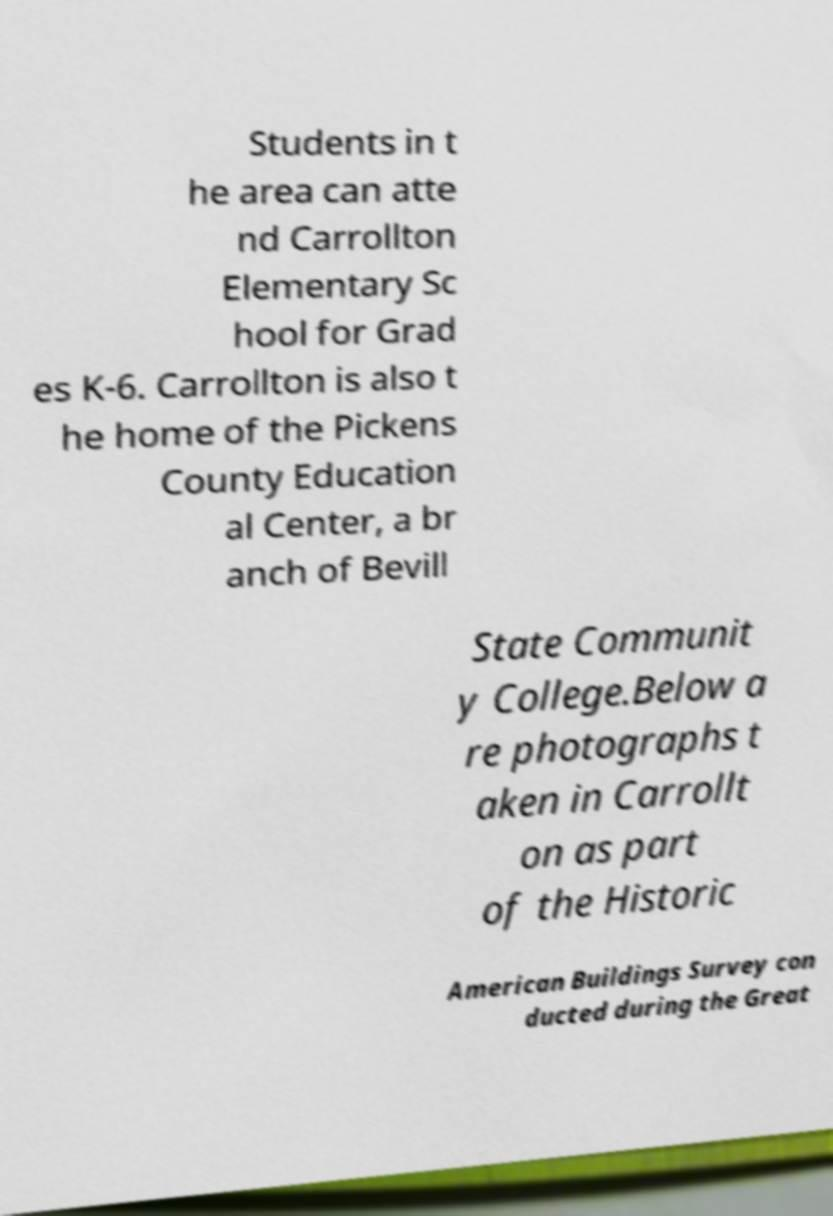There's text embedded in this image that I need extracted. Can you transcribe it verbatim? Students in t he area can atte nd Carrollton Elementary Sc hool for Grad es K-6. Carrollton is also t he home of the Pickens County Education al Center, a br anch of Bevill State Communit y College.Below a re photographs t aken in Carrollt on as part of the Historic American Buildings Survey con ducted during the Great 